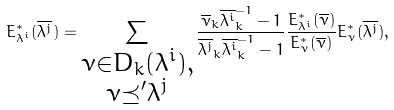<formula> <loc_0><loc_0><loc_500><loc_500>E _ { \lambda ^ { i } } ^ { * } ( \overline { \lambda ^ { j } } ) = \sum _ { \substack { \nu \in D _ { k } ( \lambda ^ { i } ) , \\ \nu \preceq ^ { \prime } \lambda ^ { j } } } \frac { \overline { \nu } _ { k } \overline { \lambda ^ { i } } _ { k } ^ { - 1 } - 1 } { \overline { \lambda ^ { j } } _ { k } \overline { \lambda ^ { i } } _ { k } ^ { - 1 } - 1 } \frac { E _ { \lambda ^ { i } } ^ { * } ( \overline { \nu } ) } { E _ { \nu } ^ { * } ( \overline { \nu } ) } E ^ { * } _ { \nu } ( \overline { \lambda ^ { j } } ) ,</formula> 